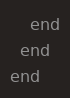Convert code to text. <code><loc_0><loc_0><loc_500><loc_500><_Elixir_>    end
  end
end
</code> 